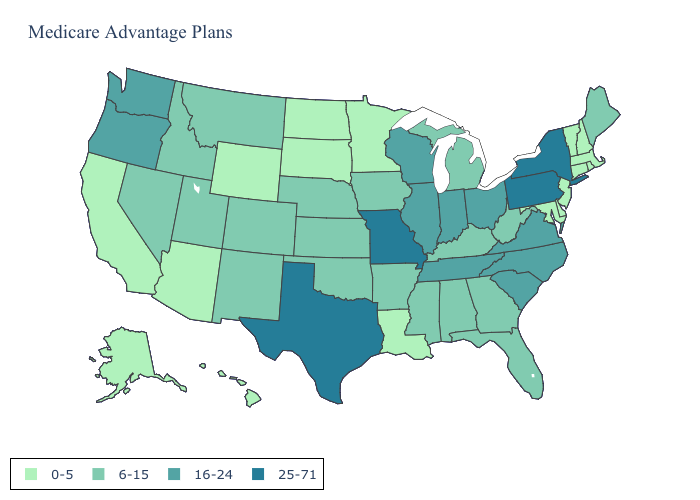Does the first symbol in the legend represent the smallest category?
Keep it brief. Yes. Does California have the highest value in the West?
Give a very brief answer. No. Which states have the lowest value in the Northeast?
Give a very brief answer. Connecticut, Massachusetts, New Hampshire, New Jersey, Rhode Island, Vermont. What is the value of Oklahoma?
Keep it brief. 6-15. What is the lowest value in states that border Delaware?
Give a very brief answer. 0-5. Which states have the lowest value in the Northeast?
Write a very short answer. Connecticut, Massachusetts, New Hampshire, New Jersey, Rhode Island, Vermont. How many symbols are there in the legend?
Quick response, please. 4. Name the states that have a value in the range 16-24?
Short answer required. Illinois, Indiana, North Carolina, Ohio, Oregon, South Carolina, Tennessee, Virginia, Washington, Wisconsin. What is the value of Mississippi?
Quick response, please. 6-15. What is the value of New Hampshire?
Quick response, please. 0-5. Which states have the lowest value in the USA?
Concise answer only. Alaska, Arizona, California, Connecticut, Delaware, Hawaii, Louisiana, Massachusetts, Maryland, Minnesota, North Dakota, New Hampshire, New Jersey, Rhode Island, South Dakota, Vermont, Wyoming. Among the states that border Missouri , which have the highest value?
Short answer required. Illinois, Tennessee. Name the states that have a value in the range 25-71?
Be succinct. Missouri, New York, Pennsylvania, Texas. Which states have the lowest value in the USA?
Short answer required. Alaska, Arizona, California, Connecticut, Delaware, Hawaii, Louisiana, Massachusetts, Maryland, Minnesota, North Dakota, New Hampshire, New Jersey, Rhode Island, South Dakota, Vermont, Wyoming. Name the states that have a value in the range 25-71?
Quick response, please. Missouri, New York, Pennsylvania, Texas. 